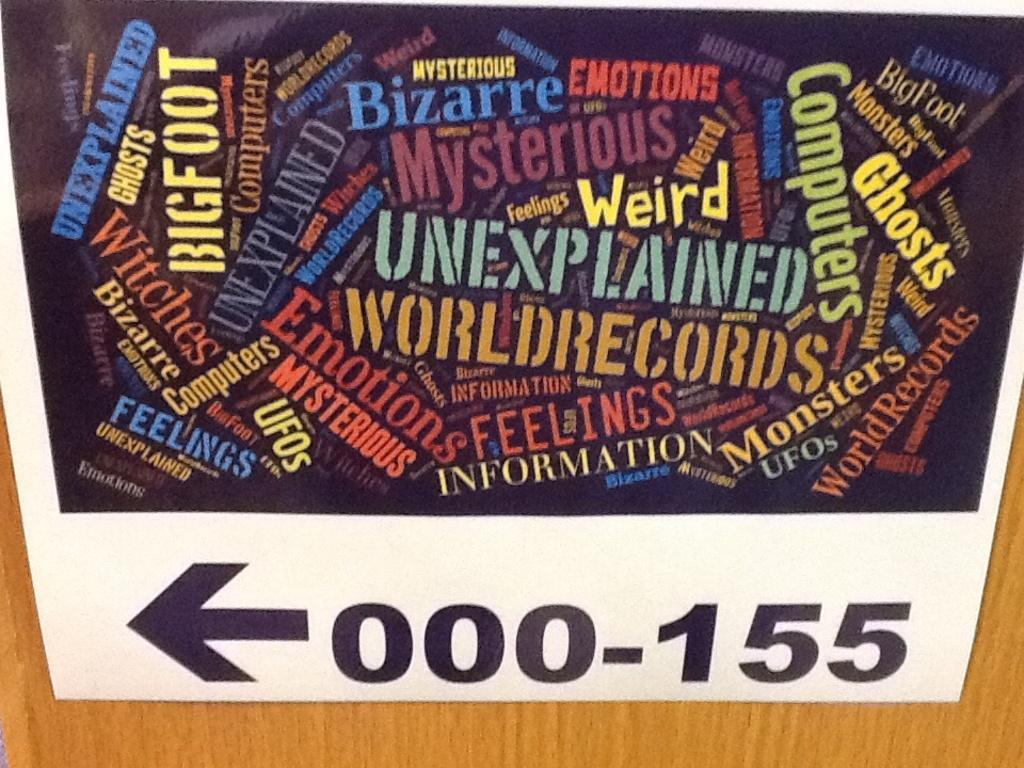Provide a one-sentence caption for the provided image. A sign shows that categories such as "unexplained, emotions, UFOs, and bigfoot are in sections 000-155 to the left. 